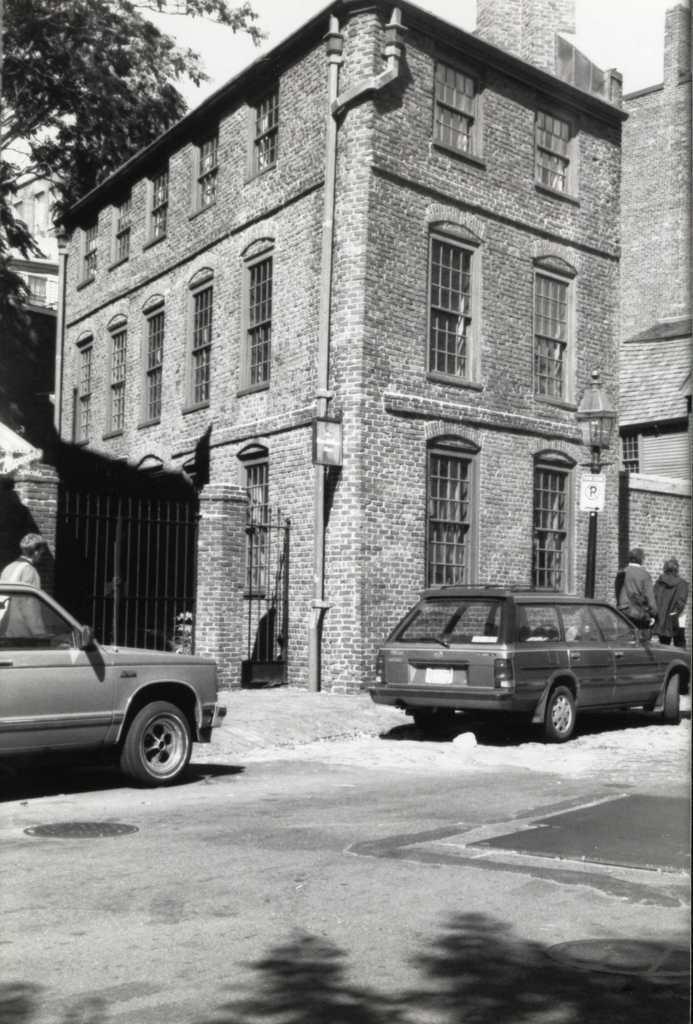Could you give a brief overview of what you see in this image? In this image in the center there are two cars and some persons, in the background there are some buildings and tree. At the bottom there is a walkway. 